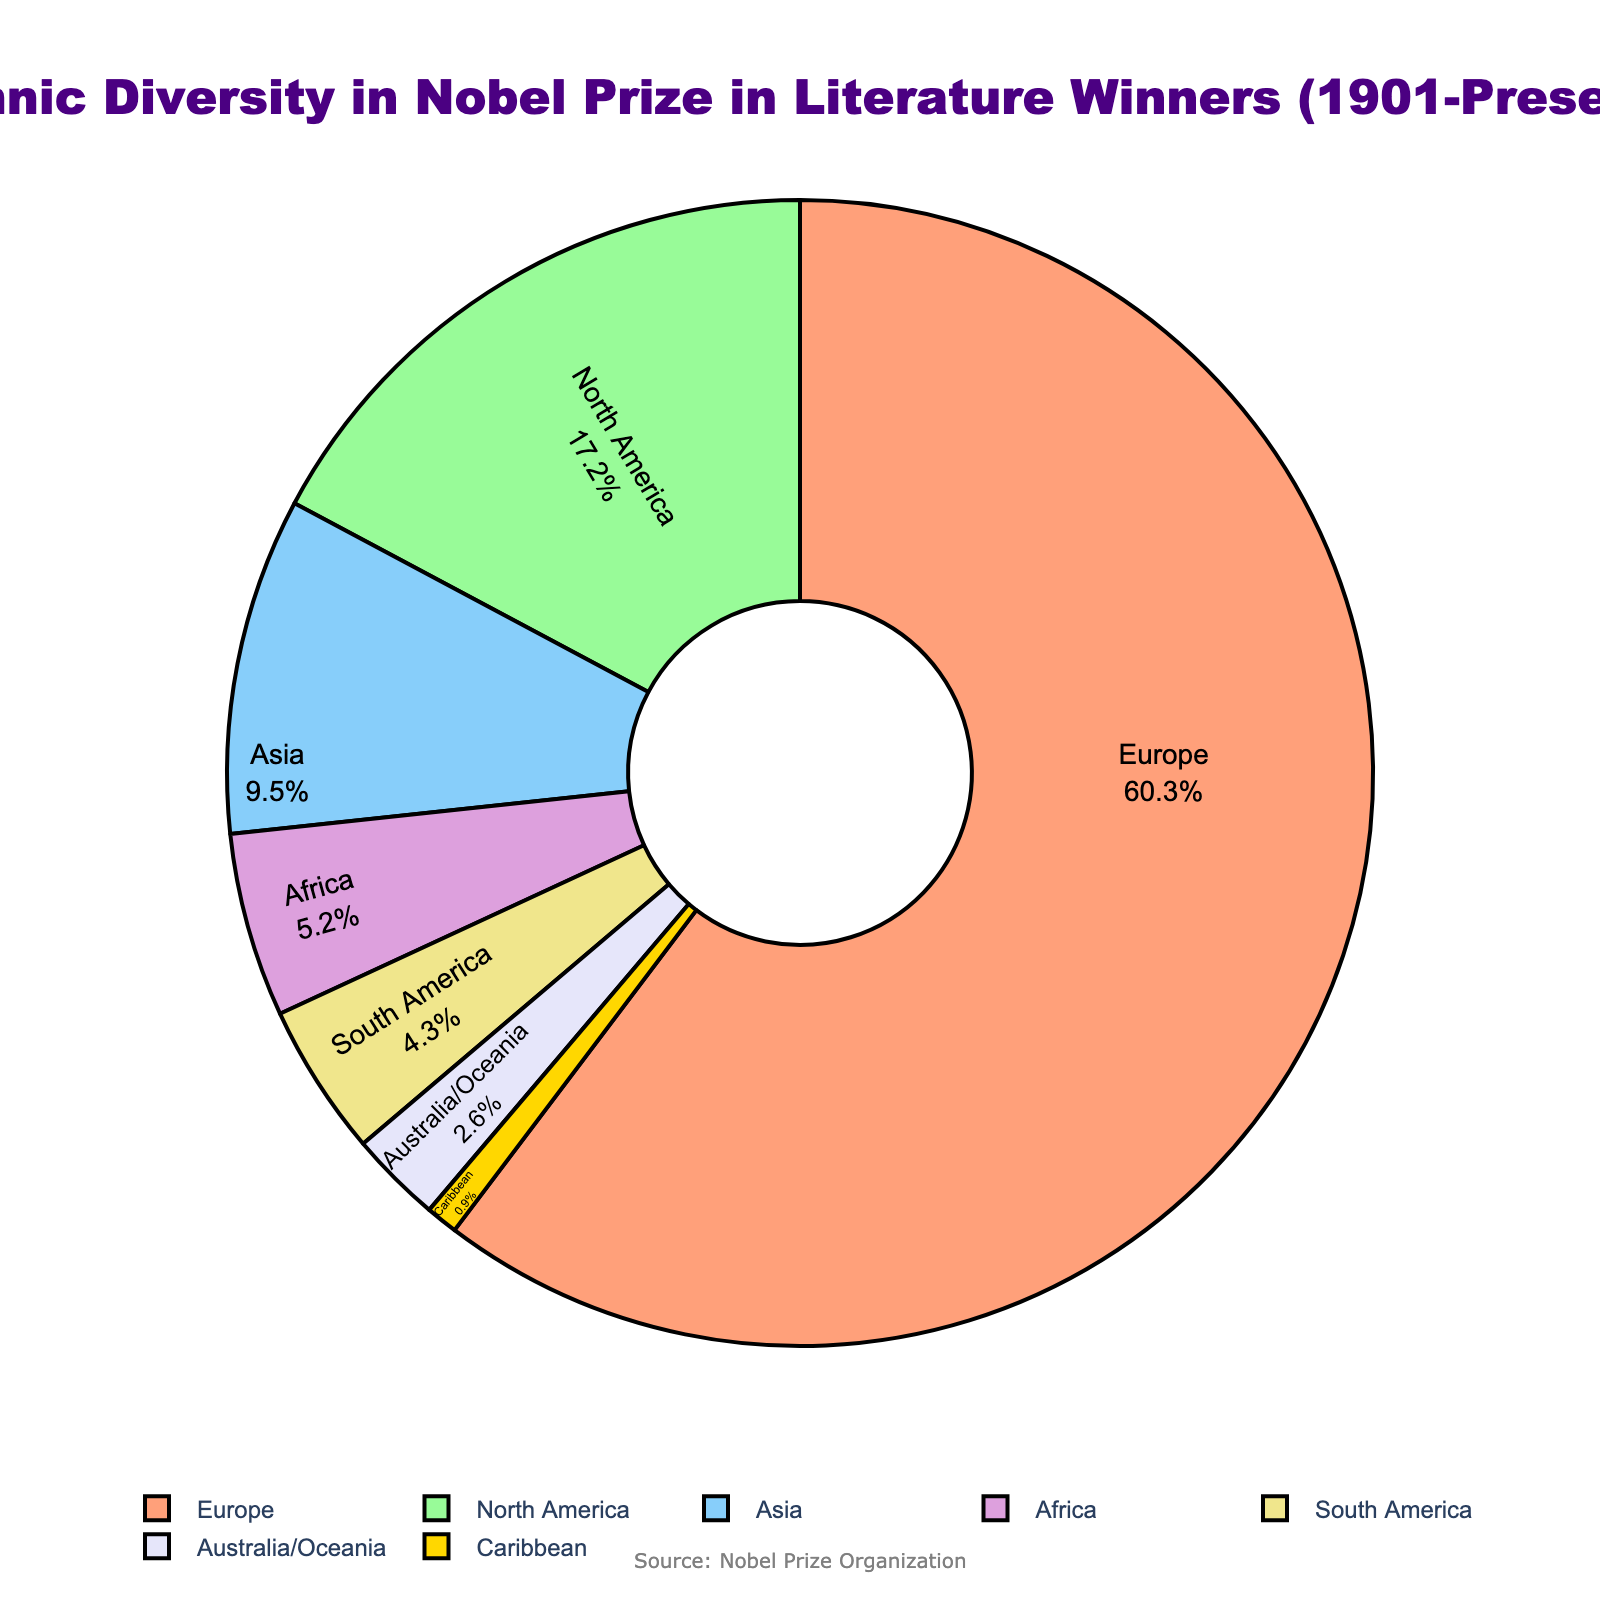What region has the highest percentage of Nobel Prize in Literature winners? The pie chart indicates that Europe has the largest slice, which represents the highest percentage.
Answer: Europe Which regions together account for over 75% of the winners? Adding the percentages for Europe (60.3%) and North America (17.2%) gives a total of 77.5%, which is more than 75%.
Answer: Europe and North America What is the difference in percentage between the regions with the highest and lowest representation? Europe has the highest percentage (60.3%) and the Caribbean has the lowest percentage (0.9%). The difference is 60.3% - 0.9% = 59.4%.
Answer: 59.4% Which region has a percentage closest to 10%? The pie chart shows Asia with 9.5%, which is closest to 10%.
Answer: Asia How much more prevalent are European winners compared to Asian winners? The percentage for Europe is 60.3% and for Asia is 9.5%. The difference is 60.3% - 9.5% = 50.8%.
Answer: 50.8% Do any regions have a similar percentage of winners (within 1%)? Examining the pie chart, South America has 4.3% and Africa has 5.2%; the difference is 0.9%, which is within 1%.
Answer: Yes, South America and Africa What is the combined percentage of winners from Africa, South America, and the Caribbean? Adding the percentages: 5.2% (Africa) + 4.3% (South America) + 0.9% (Caribbean) = 10.4%.
Answer: 10.4% Which regions have less than 5% representation in the Nobel Prize in Literature winners? The regions with less than 5% are Africa (5.2% rounded but less such true parts lower), South America (4.3%), Australia/Oceania (2.6%), and Caribbean (0.9%).
Answer: South America, Australia/Oceania, Caribbean Out of North America and Asia, which has a higher percentage and by how much? North America has 17.2% and Asia has 9.5%. The difference is 17.2% - 9.5% = 7.7%.
Answer: North America by 7.7% What is the average percentage of winners from regions outside Europe and North America? First, add the percentages of Asia (9.5%), Africa (5.2%), South America (4.3%), Australia/Oceania (2.6%), and Caribbean (0.9%): 9.5% + 5.2% + 4.3% + 2.6% + 0.9% = 22.5%. There are 5 regions, so the average is 22.5% / 5 = 4.5%.
Answer: 4.5% 